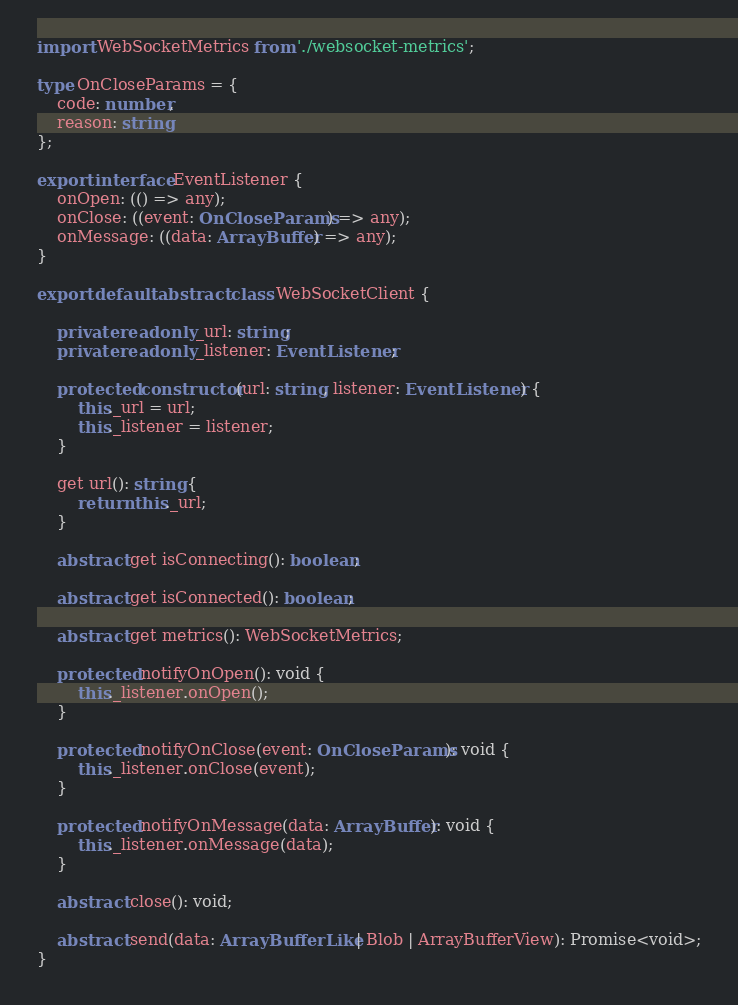<code> <loc_0><loc_0><loc_500><loc_500><_TypeScript_>import WebSocketMetrics from './websocket-metrics';

type OnCloseParams = {
    code: number,
    reason: string
};

export interface EventListener {
    onOpen: (() => any);
    onClose: ((event: OnCloseParams) => any);
    onMessage: ((data: ArrayBuffer) => any);
}

export default abstract class WebSocketClient {

    private readonly _url: string;
    private readonly _listener: EventListener;

    protected constructor(url: string, listener: EventListener) {
        this._url = url;
        this._listener = listener;
    }

    get url(): string {
        return this._url;
    }

    abstract get isConnecting(): boolean;

    abstract get isConnected(): boolean;

    abstract get metrics(): WebSocketMetrics;

    protected notifyOnOpen(): void {
        this._listener.onOpen();
    }

    protected notifyOnClose(event: OnCloseParams): void {
        this._listener.onClose(event);
    }

    protected notifyOnMessage(data: ArrayBuffer): void {
        this._listener.onMessage(data);
    }

    abstract close(): void;

    abstract send(data: ArrayBufferLike | Blob | ArrayBufferView): Promise<void>;
}
</code> 